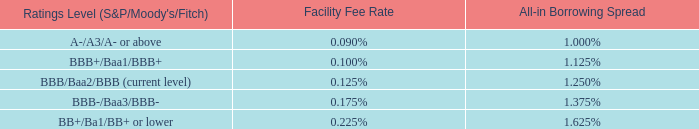Standard & Poor's Rating Services', a Standard & Poor's Financial Services LLC business ("S&P"), corporate credit rating is "BBB." Moody’s Investor Service, Inc.'s ("Moody's") applicable rating is "Baa2." Fitch Ratings', a wholly owned subsidiary of Fimlac, S.A. ("Fitch"), applicable rating is "BBB." The below table outlines the fees paid on the unused portion of the facility ("Facility Fee Rate") and letter of credit fees and borrowings ("Undrawn Letter of Credit Fee and Borrowing Spread") that corresponds to the applicable rating levels from S&P, Moody's and Fitch.
In the event the rating levels are split, the applicable fees and spread will be based upon the rating level in effect for two of the rating agencies, or, if all three rating agencies have different rating levels, the applicable fees and spread will be based upon the rating level that is between the rating levels of the other two rating agencies.
What happens when all three rating agencies have different rating levels? The applicable fees and spread will be based upon the rating level that is between the rating levels of the other two rating agencies. What percentage of the loan is the company currently paying for the unused portion of the facility? 0.125%. What are the firm's current credit rating by the three rating agencies? Standard & poor's rating services', a standard & poor's financial services llc business ("s&p"), corporate credit rating is "bbb.", moody’s investor service, inc.'s ("moody's") applicable rating is "baa2.", fitch ratings', a wholly owned subsidiary of fimlac, s.a. ("fitch"), applicable rating is "bbb.". What is the difference in Facility Fee Rate between Tyson Foods and a company with a credit rating of A-/A3/A- or above?
Answer scale should be: percent. 0.125% - 0.09%
Answer: 0.04. What is the difference between the All-in Borrowing Spread and the Facility Fee Rate for Tyson Foods currently?
Answer scale should be: percent. 1.250% - 0.125%
Answer: 1.13. Suppose the approved loan amount for Tyson Foods is $12 million. What is the Facility Fee Rate payable?
Answer scale should be: million. 0.125% * 12
Answer: 0.01. 